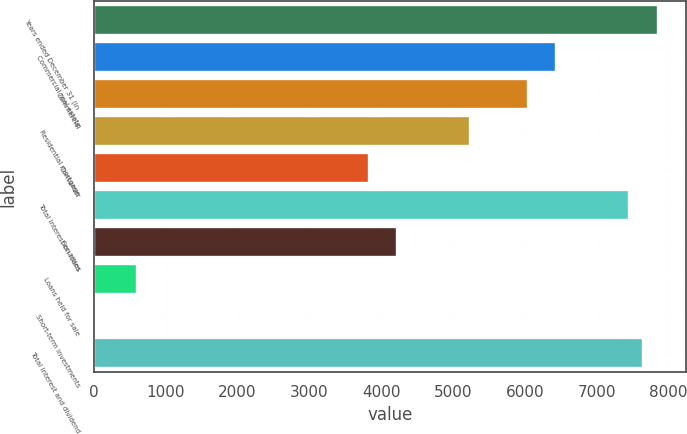Convert chart. <chart><loc_0><loc_0><loc_500><loc_500><bar_chart><fcel>Years ended December 31 (in<fcel>Commercial real estate<fcel>Commercial<fcel>Residential mortgage<fcel>Consumer<fcel>Total interest on loans<fcel>Securities<fcel>Loans held for sale<fcel>Short-term investments<fcel>Total interest and dividend<nl><fcel>7849.83<fcel>6440.94<fcel>6038.4<fcel>5233.32<fcel>3824.43<fcel>7447.29<fcel>4226.97<fcel>604.11<fcel>0.3<fcel>7648.56<nl></chart> 